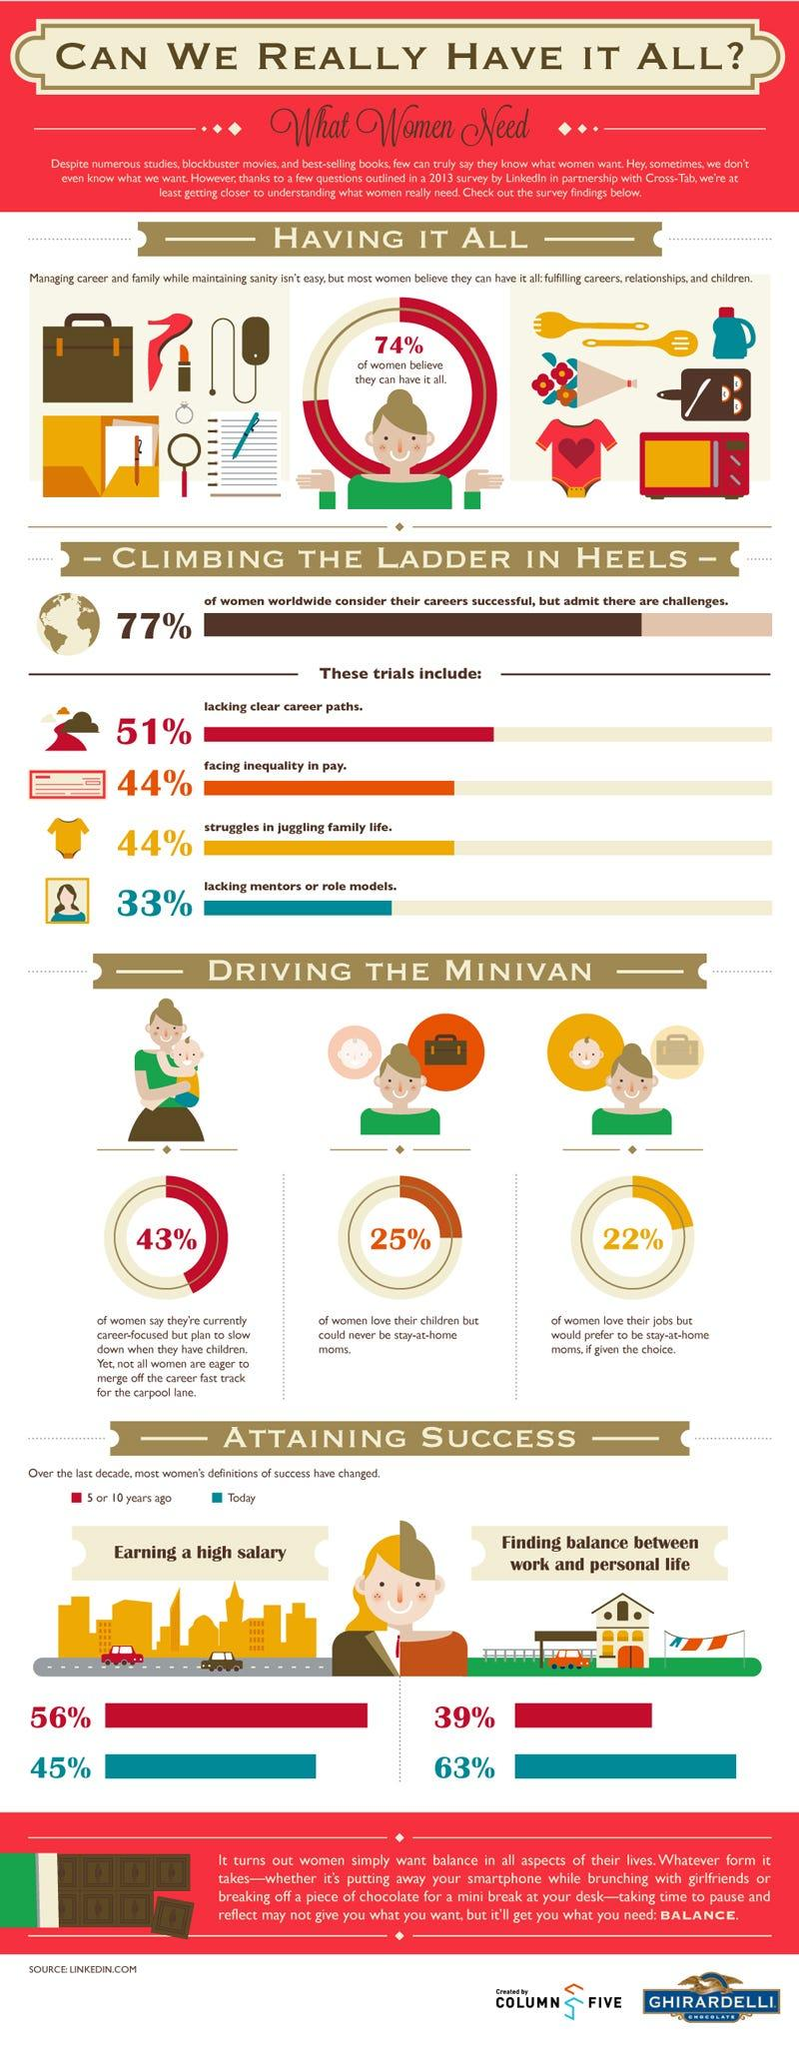Draw attention to some important aspects in this diagram. According to a recent survey, 45% of women today believe that the definition of success means earning a high salary. A recent survey conducted 5 to 10 years ago found that 39% of women believed that success meant finding the perfect work-life balance. According to a recent survey, 25% of women report loving their children but not wanting to be stay-at-home-moms. According to the survey, 43% of the women are career-oriented but plan to slow down when they have children. According to a recent survey, 74% of women believe that they are able to balance both their career and family responsibilities. 